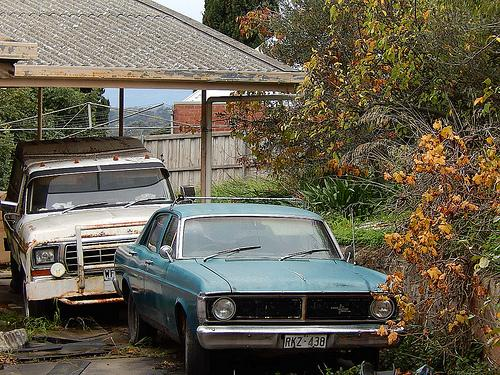What type of building is the white truck parked under? The white truck is parked under an outside garage or carport. Mention one feature of the white truck's license plate. The first 2 letters showing on the white truck's license plate are "wf". How many headlights are there on the blue car? The blue car has two headlights. Describe a detail about the white truck's roof. The white truck's roof has visible rust and discoloration. What is one notable feature of the blue car in the foreground? The blue car is a Chevy Nova. What is the condition of the trees' leaves in the image? The trees have both green and yellow dying leaves. Identify the type and color of the fence in the background. The fence is wooden and brown. Describe the condition of the vehicles in the image. Both the white truck and blue car are not new and appear to be old or rusty. List the colors of the two vehicles in the photo. The two vehicles are blue and white. What kind of vegetation is present in the background? There is overgrown vegetation with a pointy leave plant in the background. 